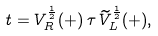<formula> <loc_0><loc_0><loc_500><loc_500>t = V _ { R } ^ { \frac { 1 } { 2 } } ( + ) \, \tau \, \widetilde { V } _ { L } ^ { \frac { 1 } { 2 } } ( + ) ,</formula> 